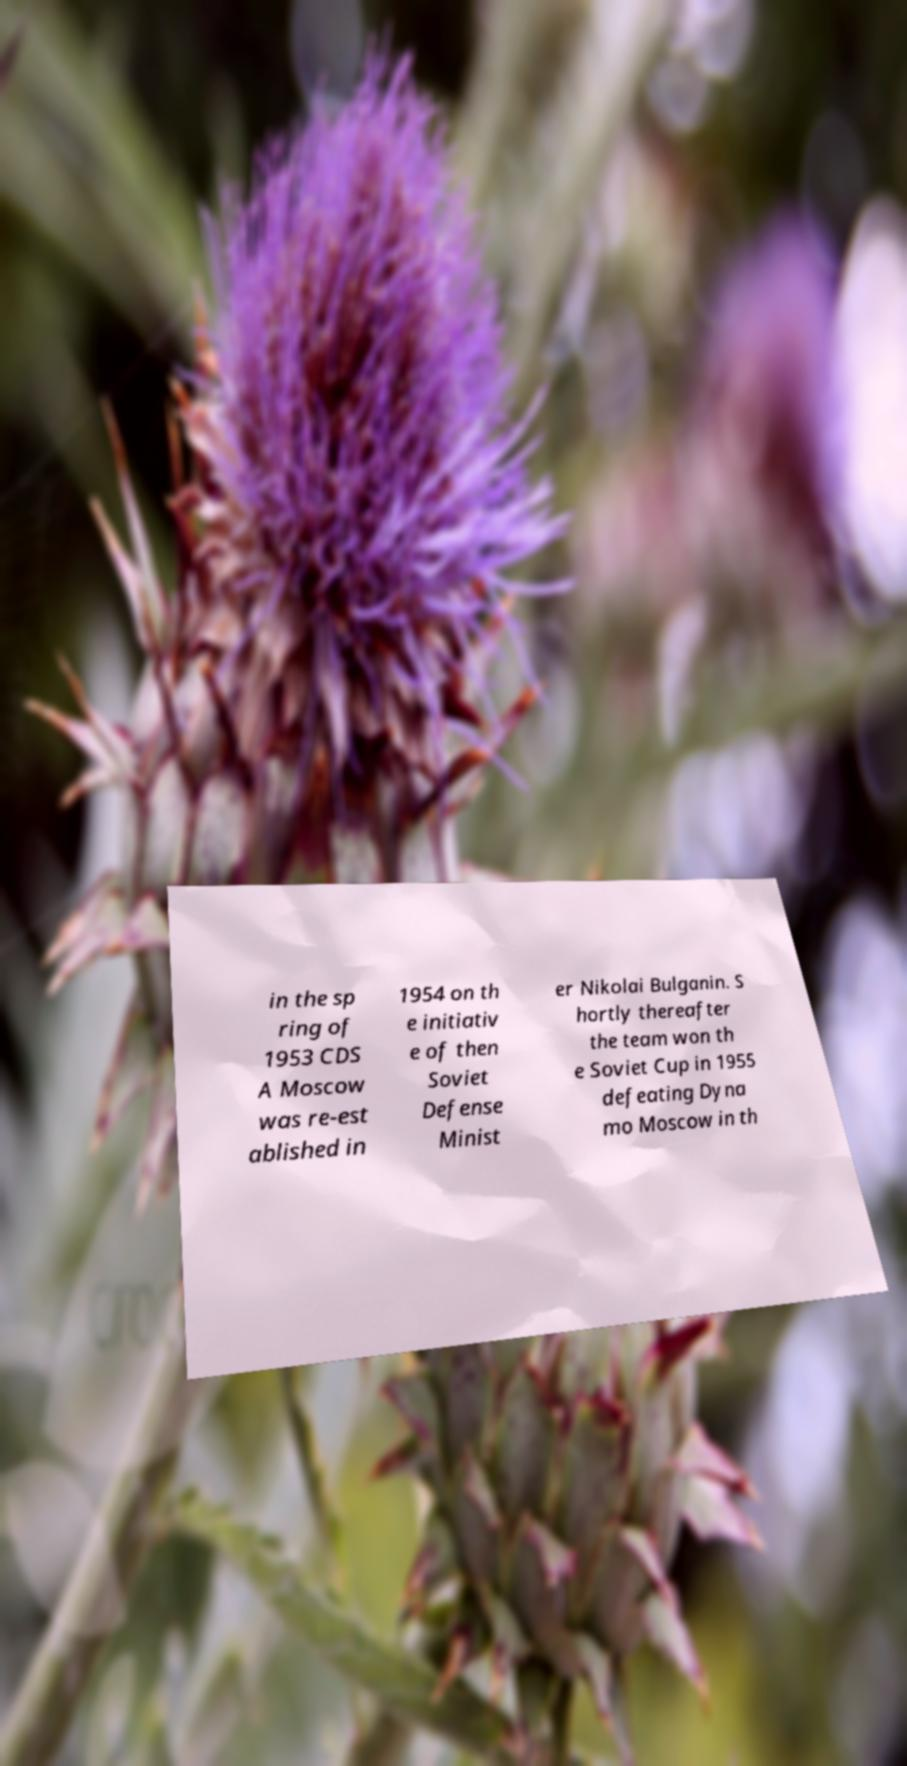Can you read and provide the text displayed in the image?This photo seems to have some interesting text. Can you extract and type it out for me? in the sp ring of 1953 CDS A Moscow was re-est ablished in 1954 on th e initiativ e of then Soviet Defense Minist er Nikolai Bulganin. S hortly thereafter the team won th e Soviet Cup in 1955 defeating Dyna mo Moscow in th 